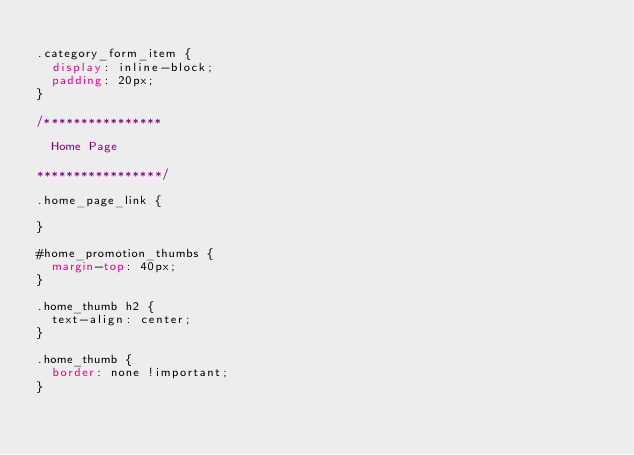Convert code to text. <code><loc_0><loc_0><loc_500><loc_500><_CSS_>
.category_form_item {
	display: inline-block;
	padding: 20px;
}

/****************

	Home Page 

*****************/

.home_page_link {

} 

#home_promotion_thumbs {
	margin-top: 40px;
}

.home_thumb h2 {
	text-align: center;
}

.home_thumb {
	border: none !important;
}



</code> 